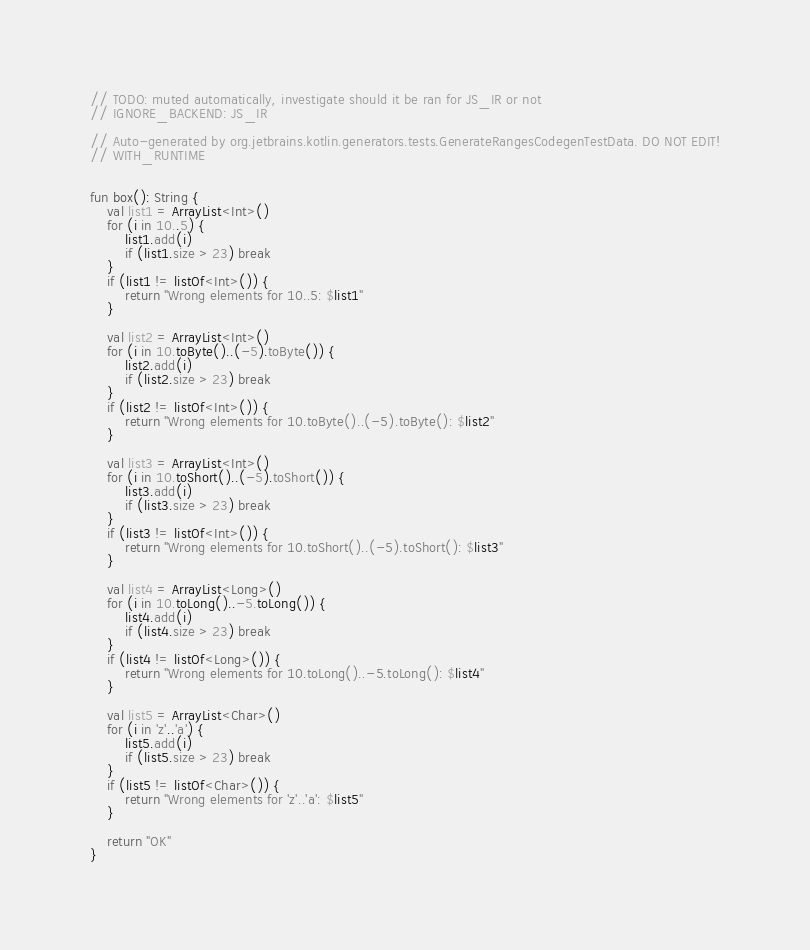<code> <loc_0><loc_0><loc_500><loc_500><_Kotlin_>// TODO: muted automatically, investigate should it be ran for JS_IR or not
// IGNORE_BACKEND: JS_IR

// Auto-generated by org.jetbrains.kotlin.generators.tests.GenerateRangesCodegenTestData. DO NOT EDIT!
// WITH_RUNTIME


fun box(): String {
    val list1 = ArrayList<Int>()
    for (i in 10..5) {
        list1.add(i)
        if (list1.size > 23) break
    }
    if (list1 != listOf<Int>()) {
        return "Wrong elements for 10..5: $list1"
    }

    val list2 = ArrayList<Int>()
    for (i in 10.toByte()..(-5).toByte()) {
        list2.add(i)
        if (list2.size > 23) break
    }
    if (list2 != listOf<Int>()) {
        return "Wrong elements for 10.toByte()..(-5).toByte(): $list2"
    }

    val list3 = ArrayList<Int>()
    for (i in 10.toShort()..(-5).toShort()) {
        list3.add(i)
        if (list3.size > 23) break
    }
    if (list3 != listOf<Int>()) {
        return "Wrong elements for 10.toShort()..(-5).toShort(): $list3"
    }

    val list4 = ArrayList<Long>()
    for (i in 10.toLong()..-5.toLong()) {
        list4.add(i)
        if (list4.size > 23) break
    }
    if (list4 != listOf<Long>()) {
        return "Wrong elements for 10.toLong()..-5.toLong(): $list4"
    }

    val list5 = ArrayList<Char>()
    for (i in 'z'..'a') {
        list5.add(i)
        if (list5.size > 23) break
    }
    if (list5 != listOf<Char>()) {
        return "Wrong elements for 'z'..'a': $list5"
    }

    return "OK"
}
</code> 